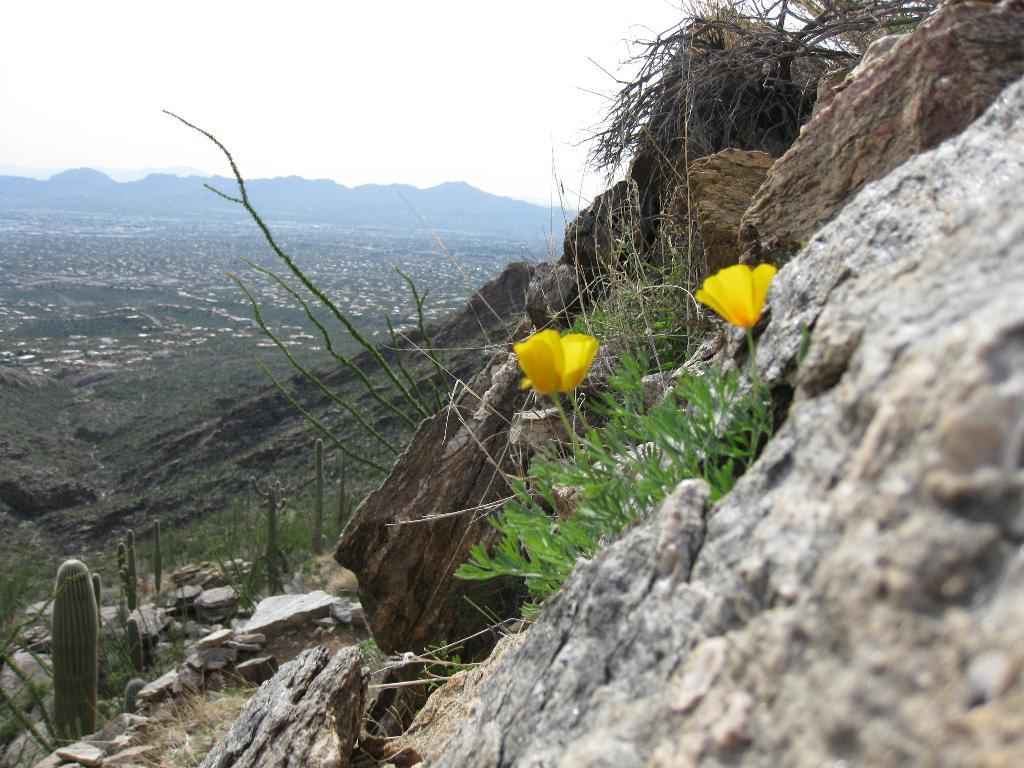What type of natural objects can be seen in the image? There are rocks in the image. What type of plant is present in the image? There is a plant with flowers in the image. What other type of plant can be seen in the image? There are cactus plants in the image. What can be seen in the distance in the image? There are hills visible in the background of the image. What is visible above the hills in the image? The sky is visible in the background of the image. What type of tax is being discussed in the image? There is no discussion of taxes in the image; it features natural objects and landscape features. 